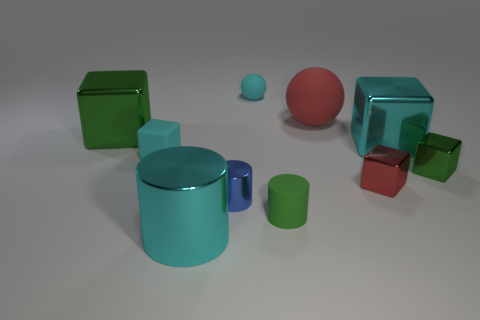There is a large shiny object that is in front of the tiny rubber thing in front of the rubber cube that is to the left of the tiny red object; what is its color?
Your answer should be very brief. Cyan. How many other objects are there of the same shape as the big green thing?
Ensure brevity in your answer.  4. Are there any metal things right of the cyan thing that is behind the large green thing?
Your answer should be compact. Yes. How many metal objects are small yellow blocks or small cyan objects?
Offer a very short reply. 0. What is the thing that is behind the rubber block and left of the cyan shiny cylinder made of?
Provide a short and direct response. Metal. There is a big metallic block that is to the left of the ball that is behind the large red rubber thing; are there any tiny green matte objects right of it?
Provide a short and direct response. Yes. Is there any other thing that is made of the same material as the cyan sphere?
Your answer should be compact. Yes. What shape is the red thing that is the same material as the cyan cylinder?
Your answer should be very brief. Cube. Are there fewer tiny red blocks that are behind the cyan ball than tiny matte balls that are left of the large green metallic object?
Offer a very short reply. No. What number of small objects are shiny cylinders or red shiny objects?
Keep it short and to the point. 2. 